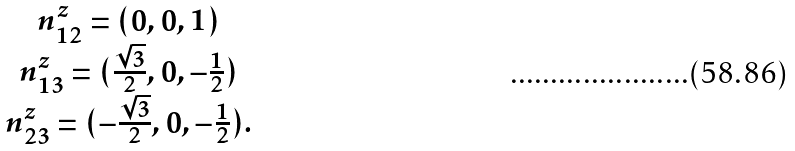Convert formula to latex. <formula><loc_0><loc_0><loc_500><loc_500>\begin{array} { c } { n } _ { 1 2 } ^ { z } = ( 0 , 0 , 1 ) \\ { n } _ { 1 3 } ^ { z } = ( \frac { \sqrt { 3 } } { 2 } , 0 , - \frac { 1 } { 2 } ) \\ { n } _ { 2 3 } ^ { z } = ( - \frac { \sqrt { 3 } } { 2 } , 0 , - \frac { 1 } { 2 } ) . \end{array}</formula> 